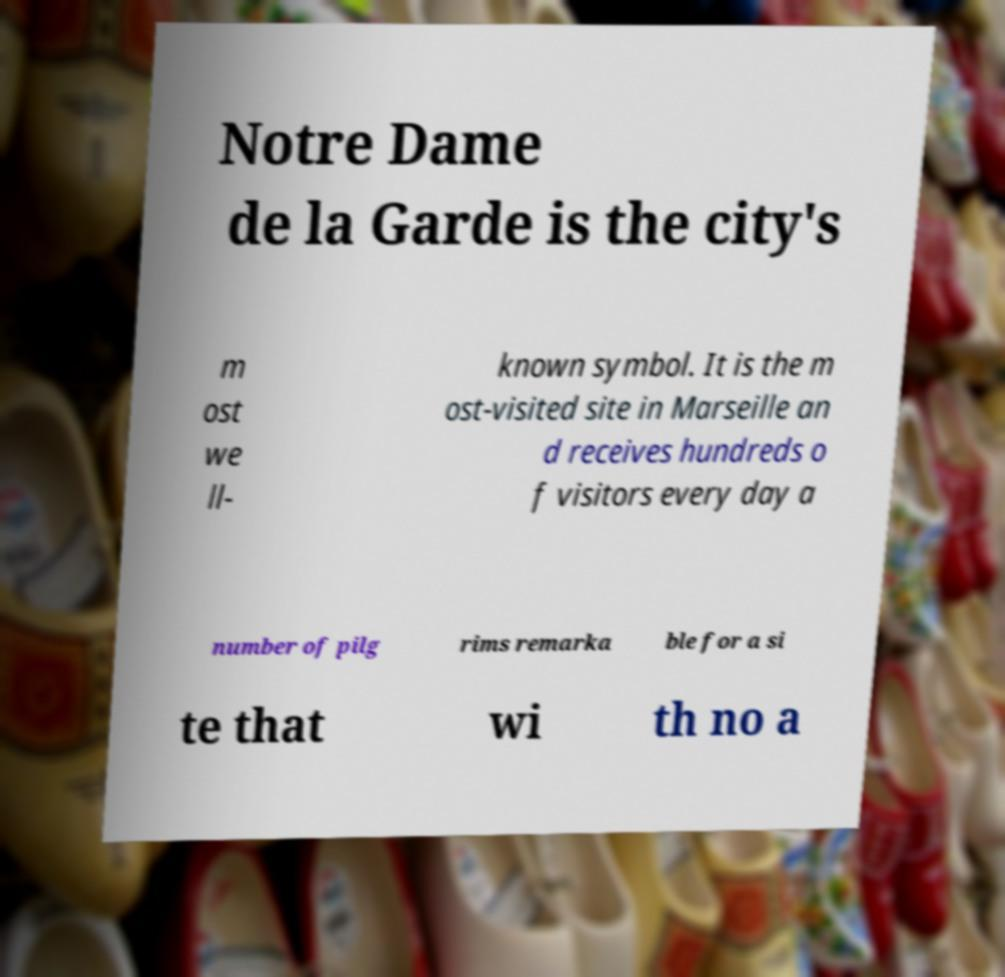I need the written content from this picture converted into text. Can you do that? Notre Dame de la Garde is the city's m ost we ll- known symbol. It is the m ost-visited site in Marseille an d receives hundreds o f visitors every day a number of pilg rims remarka ble for a si te that wi th no a 